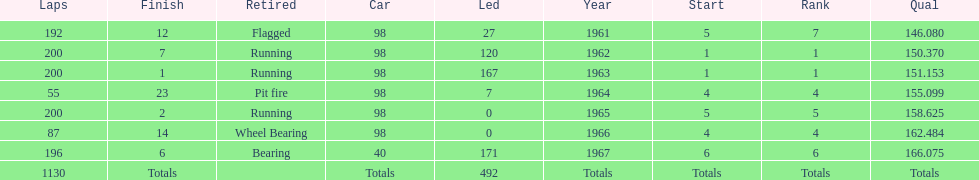What car ranked #1 from 1962-1963? 98. 